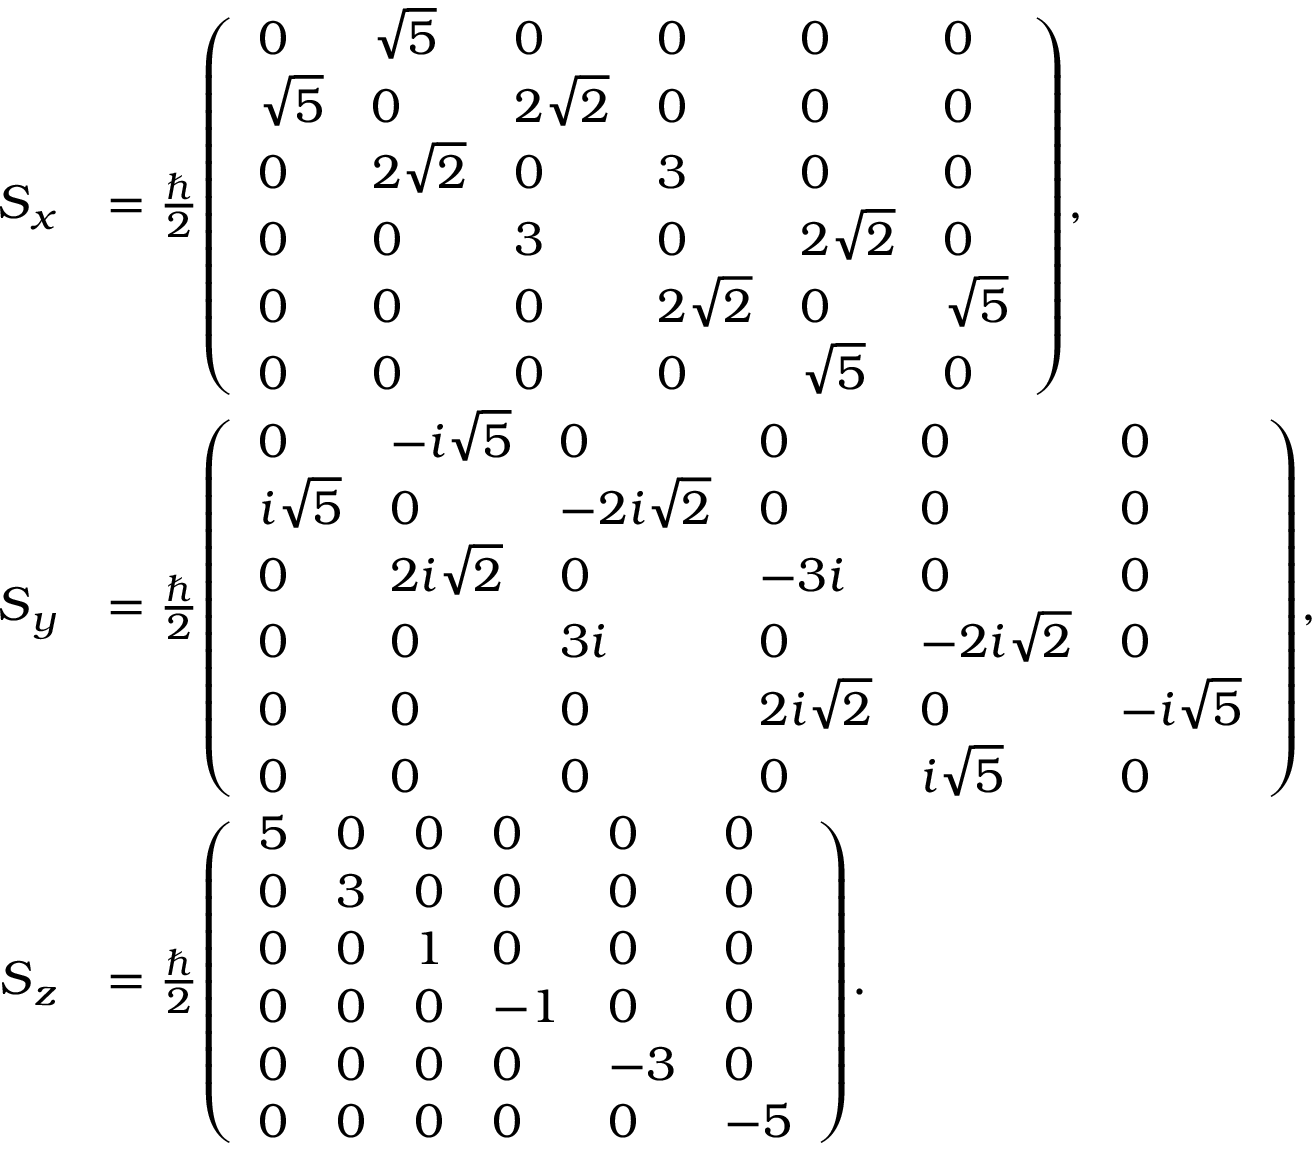<formula> <loc_0><loc_0><loc_500><loc_500>{ \begin{array} { r l } { { S } _ { x } } & { = { \frac { } { 2 } } { \left ( \begin{array} { l l l l l l } { 0 } & { { \sqrt { 5 } } } & { 0 } & { 0 } & { 0 } & { 0 } \\ { { \sqrt { 5 } } } & { 0 } & { 2 { \sqrt { 2 } } } & { 0 } & { 0 } & { 0 } \\ { 0 } & { 2 { \sqrt { 2 } } } & { 0 } & { 3 } & { 0 } & { 0 } \\ { 0 } & { 0 } & { 3 } & { 0 } & { 2 { \sqrt { 2 } } } & { 0 } \\ { 0 } & { 0 } & { 0 } & { 2 { \sqrt { 2 } } } & { 0 } & { { \sqrt { 5 } } } \\ { 0 } & { 0 } & { 0 } & { 0 } & { { \sqrt { 5 } } } & { 0 } \end{array} \right ) } , } \\ { { S } _ { y } } & { = { \frac { } { 2 } } { \left ( \begin{array} { l l l l l l } { 0 } & { - i { \sqrt { 5 } } } & { 0 } & { 0 } & { 0 } & { 0 } \\ { i { \sqrt { 5 } } } & { 0 } & { - 2 i { \sqrt { 2 } } } & { 0 } & { 0 } & { 0 } \\ { 0 } & { 2 i { \sqrt { 2 } } } & { 0 } & { - 3 i } & { 0 } & { 0 } \\ { 0 } & { 0 } & { 3 i } & { 0 } & { - 2 i { \sqrt { 2 } } } & { 0 } \\ { 0 } & { 0 } & { 0 } & { 2 i { \sqrt { 2 } } } & { 0 } & { - i { \sqrt { 5 } } } \\ { 0 } & { 0 } & { 0 } & { 0 } & { i { \sqrt { 5 } } } & { 0 } \end{array} \right ) } , } \\ { { S } _ { z } } & { = { \frac { } { 2 } } { \left ( \begin{array} { l l l l l l } { 5 } & { 0 } & { 0 } & { 0 } & { 0 } & { 0 } \\ { 0 } & { 3 } & { 0 } & { 0 } & { 0 } & { 0 } \\ { 0 } & { 0 } & { 1 } & { 0 } & { 0 } & { 0 } \\ { 0 } & { 0 } & { 0 } & { - 1 } & { 0 } & { 0 } \\ { 0 } & { 0 } & { 0 } & { 0 } & { - 3 } & { 0 } \\ { 0 } & { 0 } & { 0 } & { 0 } & { 0 } & { - 5 } \end{array} \right ) } . } \end{array} }</formula> 